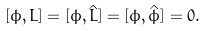<formula> <loc_0><loc_0><loc_500><loc_500>[ \phi , L ] = [ \phi , { \hat { L } } ] = [ \phi , { \hat { \phi } } ] = 0 .</formula> 